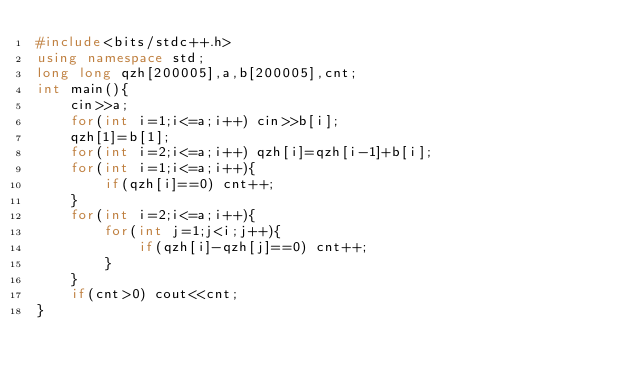<code> <loc_0><loc_0><loc_500><loc_500><_C++_>#include<bits/stdc++.h>
using namespace std;
long long qzh[200005],a,b[200005],cnt;
int main(){
	cin>>a;
	for(int i=1;i<=a;i++) cin>>b[i];
	qzh[1]=b[1];
	for(int i=2;i<=a;i++) qzh[i]=qzh[i-1]+b[i];
	for(int i=1;i<=a;i++){
		if(qzh[i]==0) cnt++;
    }
	for(int i=2;i<=a;i++){
		for(int j=1;j<i;j++){
			if(qzh[i]-qzh[j]==0) cnt++;
		}
	}
	if(cnt>0) cout<<cnt;
}</code> 